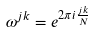<formula> <loc_0><loc_0><loc_500><loc_500>\omega ^ { j k } = e ^ { 2 \pi i \frac { j k } { N } }</formula> 